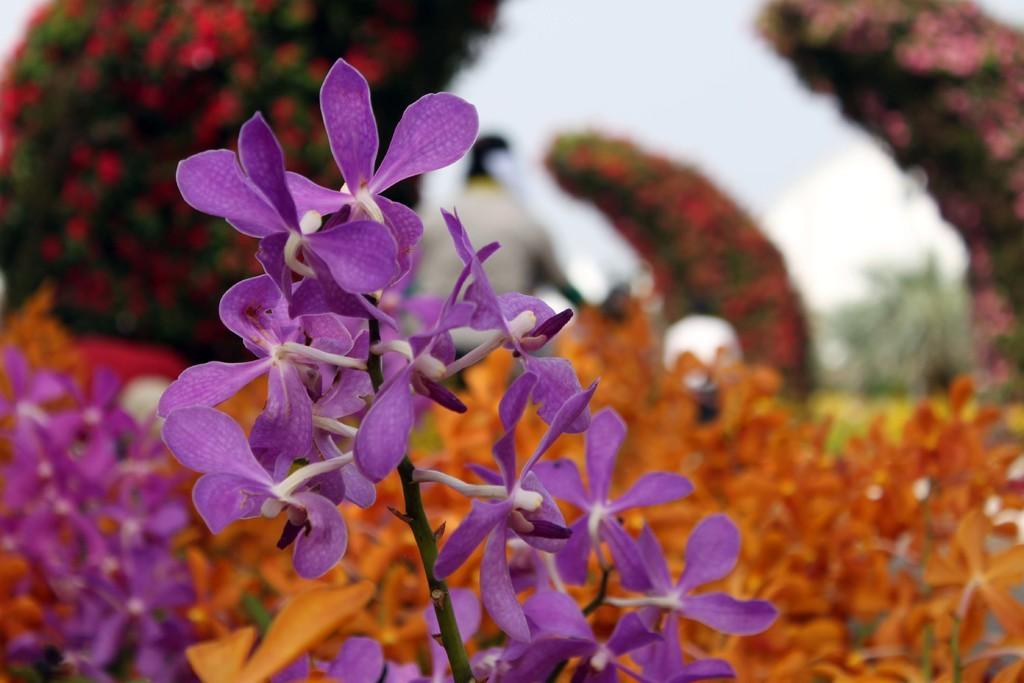In one or two sentences, can you explain what this image depicts? In this picture we can see some flowers to the plants, behind we can see flowers arch and we can see a person. 